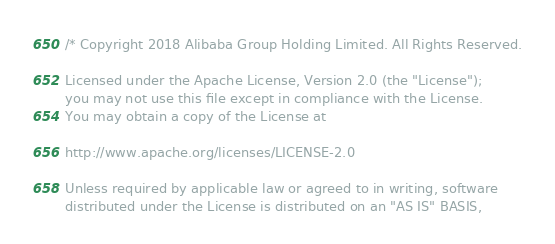<code> <loc_0><loc_0><loc_500><loc_500><_C++_>/* Copyright 2018 Alibaba Group Holding Limited. All Rights Reserved.

Licensed under the Apache License, Version 2.0 (the "License");
you may not use this file except in compliance with the License.
You may obtain a copy of the License at

http://www.apache.org/licenses/LICENSE-2.0

Unless required by applicable law or agreed to in writing, software
distributed under the License is distributed on an "AS IS" BASIS,</code> 